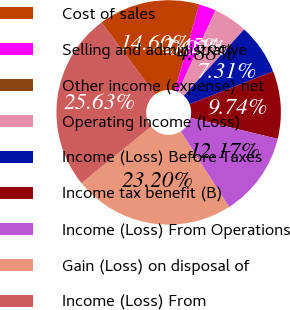<chart> <loc_0><loc_0><loc_500><loc_500><pie_chart><fcel>Cost of sales<fcel>Selling and administrative<fcel>Other income (expense) net<fcel>Operating Income (Loss)<fcel>Income (Loss) Before Taxes<fcel>Income tax benefit (B)<fcel>Income (Loss) From Operations<fcel>Gain (Loss) on disposal of<fcel>Income (Loss) From<nl><fcel>14.6%<fcel>2.45%<fcel>0.02%<fcel>4.88%<fcel>7.31%<fcel>9.74%<fcel>12.17%<fcel>23.2%<fcel>25.63%<nl></chart> 